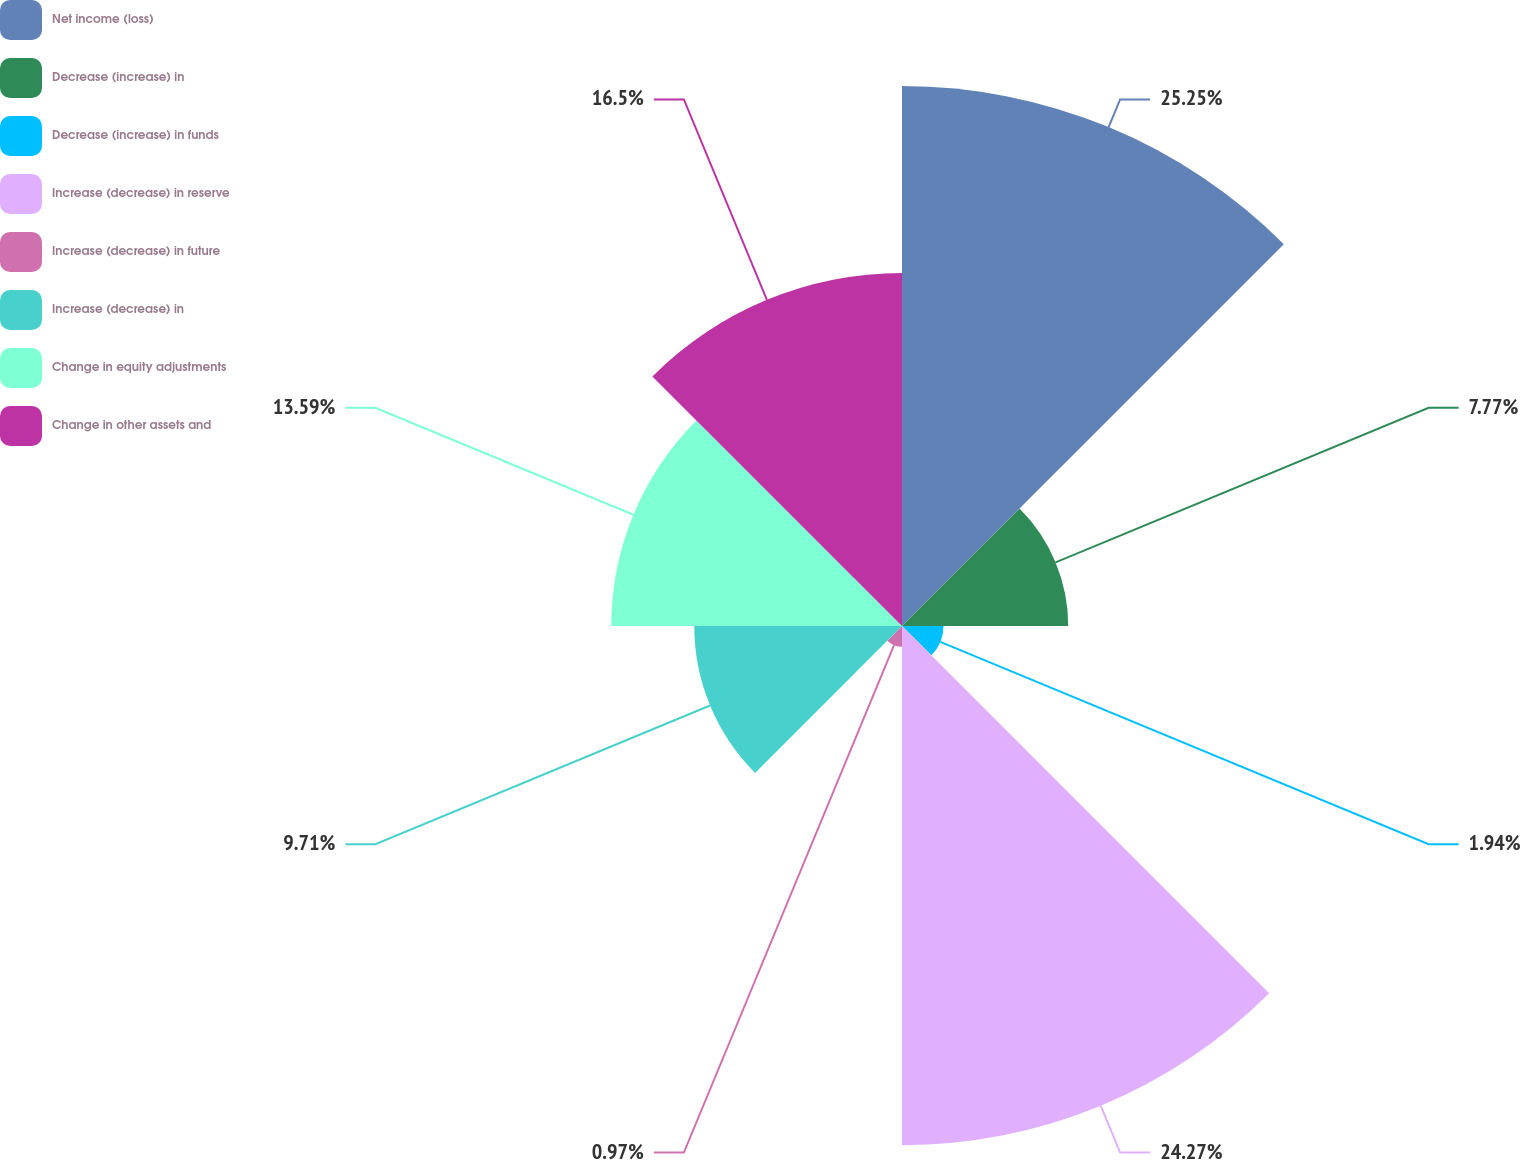<chart> <loc_0><loc_0><loc_500><loc_500><pie_chart><fcel>Net income (loss)<fcel>Decrease (increase) in<fcel>Decrease (increase) in funds<fcel>Increase (decrease) in reserve<fcel>Increase (decrease) in future<fcel>Increase (decrease) in<fcel>Change in equity adjustments<fcel>Change in other assets and<nl><fcel>25.24%<fcel>7.77%<fcel>1.94%<fcel>24.27%<fcel>0.97%<fcel>9.71%<fcel>13.59%<fcel>16.5%<nl></chart> 